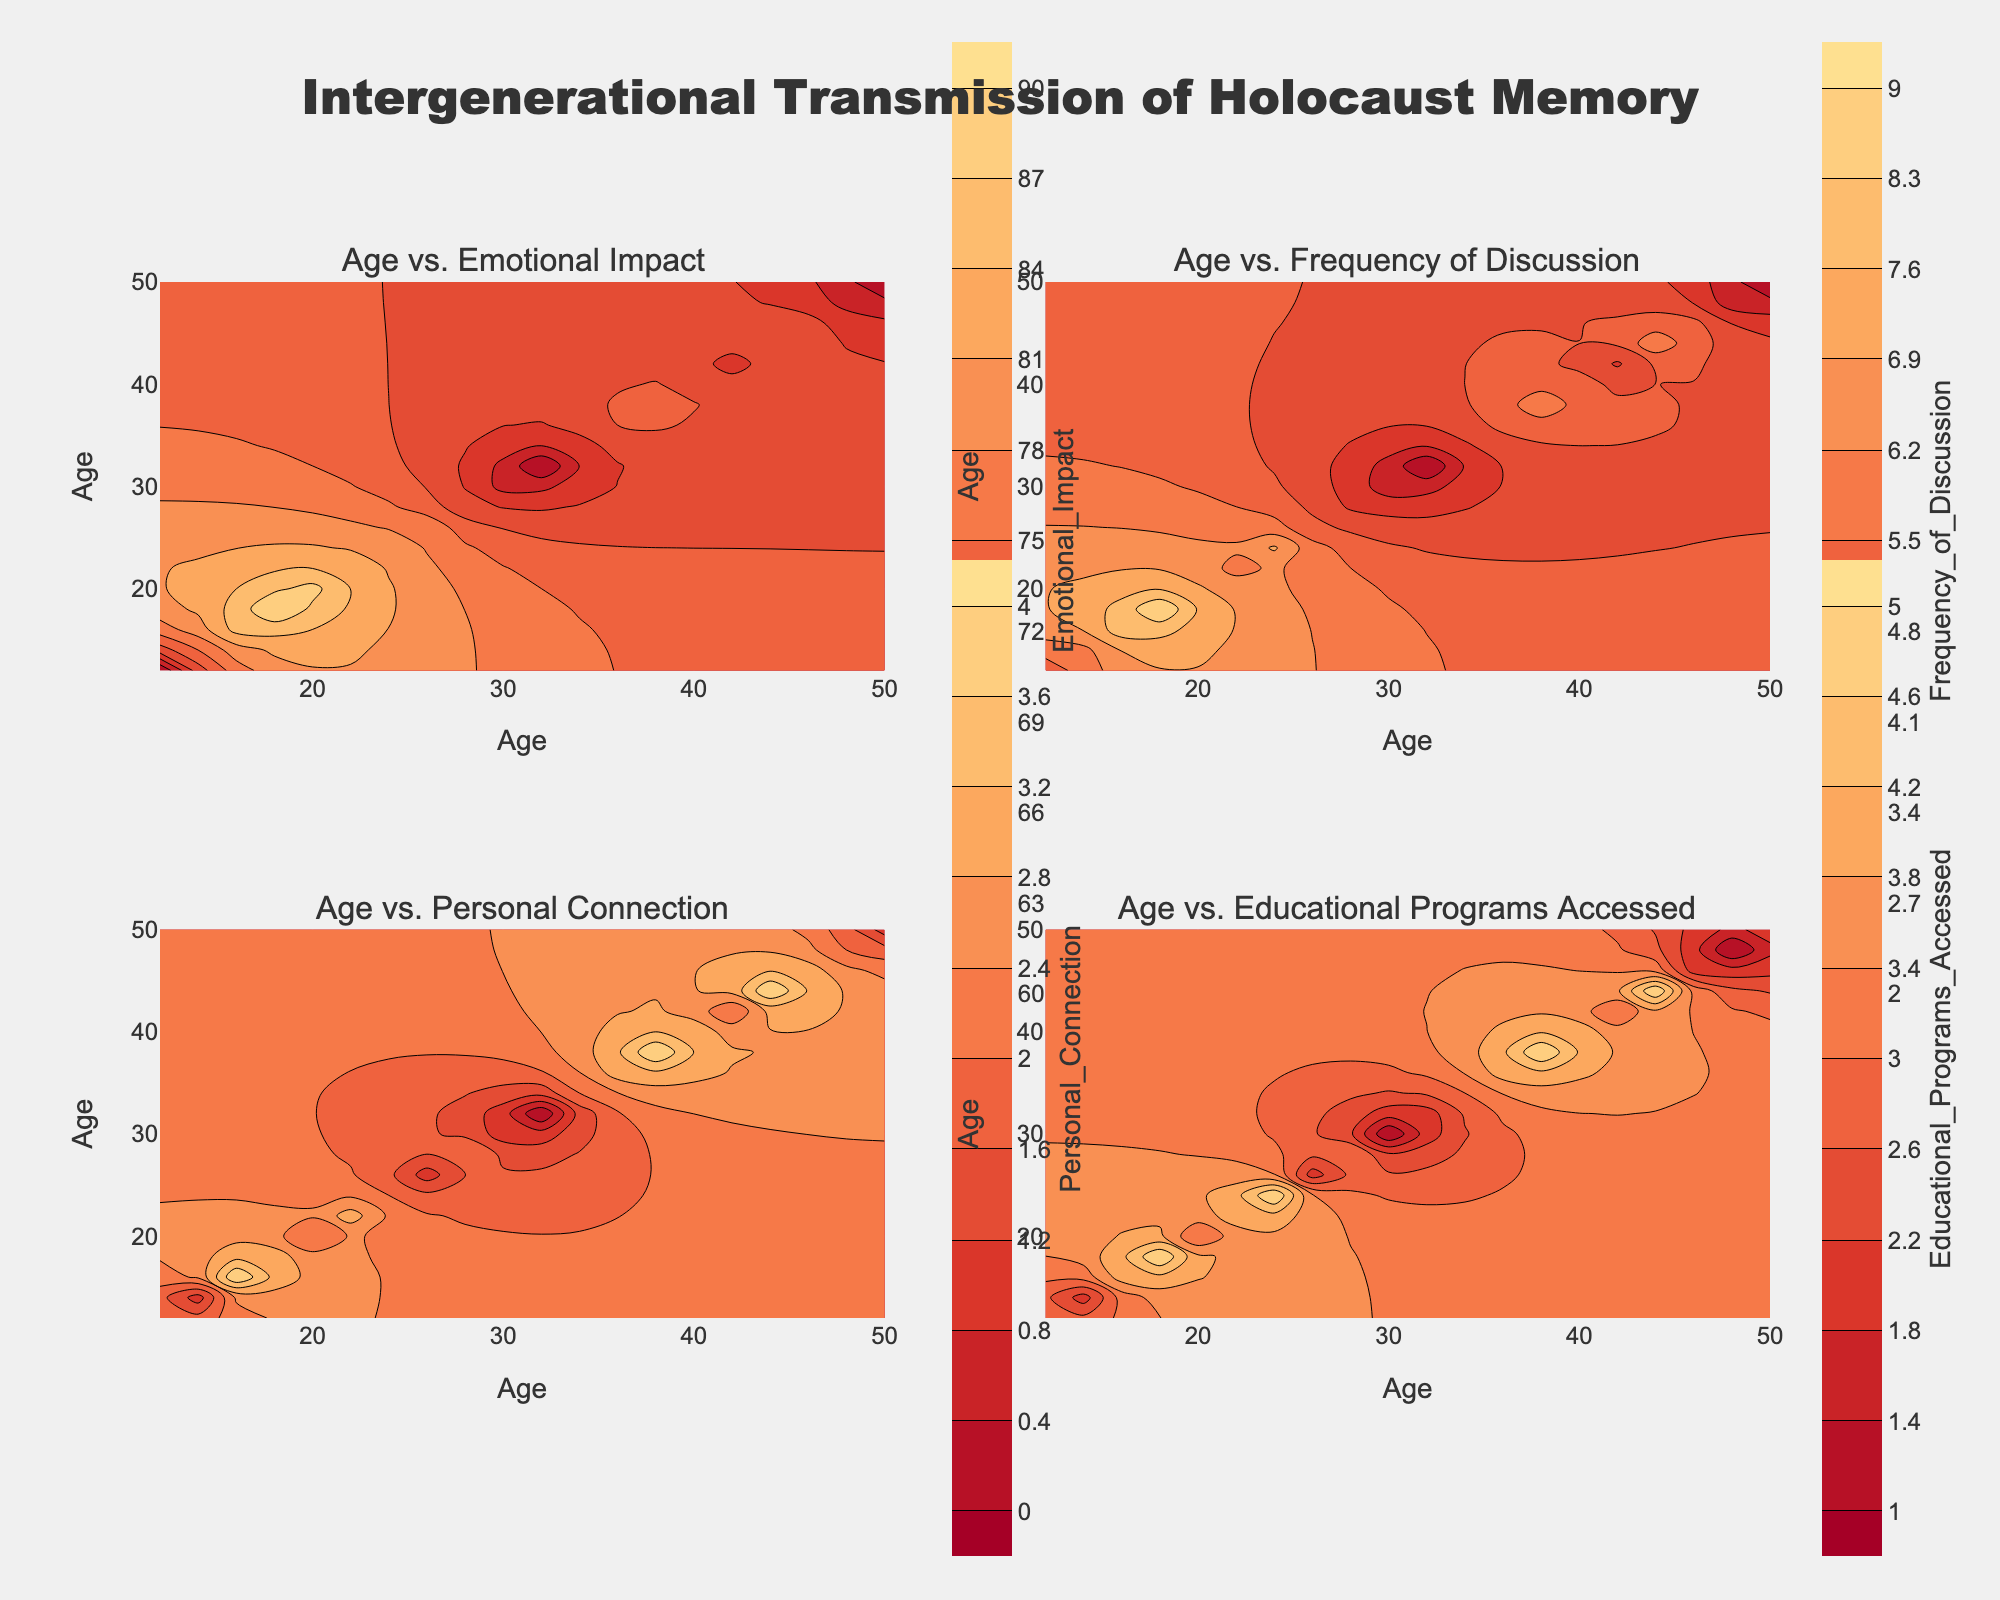What is the title of the plot? The title is prominently displayed at the top of the plot. It reads "Intergenerational Transmission of Holocaust Memory".
Answer: Intergenerational Transmission of Holocaust Memory What does the x-axis represent? The title of the x-axis, visible at the bottom of the subplots, labels it as "Age".
Answer: Age What colors are used in the contour plot? The contour plot uses a range of colors including shades of red and yellow, progressing from darker to lighter hues.
Answer: Shades of red and yellow What is the range of Emotional Impact values displayed in the Age vs. Emotional Impact subplot? The title of this subplot is "Age vs. Emotional Impact", and the contour has a color scale that helps identify the range of values. The start value is 60 and the end value is 90.
Answer: 60 to 90 Which age range has the highest Frequency of Discussion value? In the subplot titled "Age vs. Frequency of Discussion", the area with the most intense color (deep red) represents the highest value. The highest value is around the ages of 16 to 18.
Answer: 16 to 18 How does Emotional Impact vary between ages 12 and 18? Looking at the subplot "Age vs. Emotional Impact", the Emotional Impact value increases from around 60 at age 12 to 90 at age 18.
Answer: It increases Which has a higher Personal Connection value: age 24 or age 40? In the subplot titled "Age vs. Personal Connection", compare the values at ages 24 and 40 using the contour colors. Age 24 is marked with a lighter color compared to age 40.
Answer: Age 40 What is the difference in Emotional Impact between ages 20 and 50? In the subplot titled "Age vs. Emotional Impact", identify the values for ages 20 and 50. The values are 88 and 60 respectively. Subtract the two values to get the difference. 88 - 60 = 28.
Answer: 28 Which subplot shows the highest variability in values? Evaluate each subplot for the range and variation in colors. The "Age vs. Emotional Impact" subplot shows the highest variability as it covers a wider range of colors from dark red to yellow.
Answer: Age vs. Emotional Impact In the "Age vs. Educational Programs Accessed" subplot, which color represents the highest value? Refer to the legend and color scale in this subplot. The deepest red, which is most intense, represents the highest value.
Answer: Deepest red What is the relationship between age and access to educational programs? Examine the "Age vs. Educational Programs Accessed" subplot. There is a notable peak in access between the ages 16 to 18 and again around ages 36 to 38, indicating two higher points.
Answer: Peaks at 16-18 and 36-38 